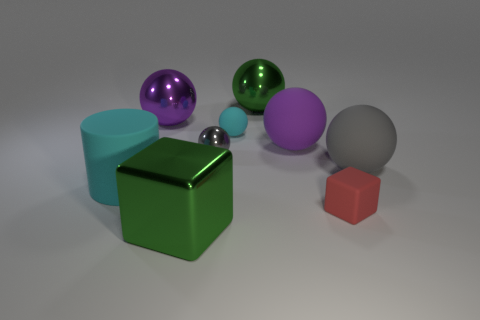Do the big purple rubber object and the red matte thing have the same shape?
Give a very brief answer. No. What color is the metallic object that is behind the large purple sphere to the left of the gray metallic thing?
Provide a short and direct response. Green. There is a sphere that is the same size as the gray metal object; what color is it?
Give a very brief answer. Cyan. What number of metal things are big purple objects or cubes?
Ensure brevity in your answer.  2. There is a green object that is behind the red block; how many metal objects are to the left of it?
Offer a terse response. 3. What size is the matte sphere that is the same color as the cylinder?
Provide a succinct answer. Small. How many objects are shiny spheres or purple balls that are right of the large green block?
Provide a succinct answer. 4. Is there a big object made of the same material as the tiny block?
Offer a very short reply. Yes. How many big green objects are behind the matte block and in front of the tiny metallic object?
Ensure brevity in your answer.  0. What material is the gray ball behind the gray rubber object?
Make the answer very short. Metal. 